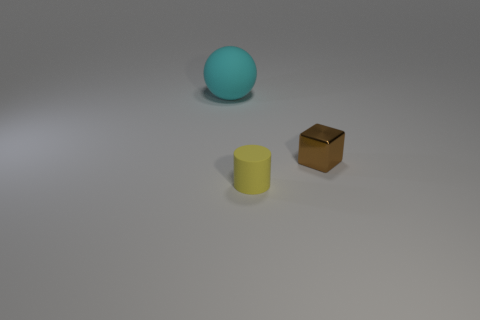What number of cyan rubber spheres have the same size as the brown shiny cube?
Your answer should be compact. 0. Does the small brown cube have the same material as the thing to the left of the small yellow rubber cylinder?
Your response must be concise. No. Are there fewer large gray matte things than tiny matte objects?
Ensure brevity in your answer.  Yes. Is there any other thing of the same color as the shiny block?
Offer a terse response. No. What is the shape of the big thing that is made of the same material as the cylinder?
Provide a succinct answer. Sphere. How many large balls are behind the rubber object right of the object to the left of the small yellow thing?
Your response must be concise. 1. The object that is both on the left side of the brown metal cube and behind the small yellow matte thing has what shape?
Your answer should be compact. Sphere. Is the number of cyan balls in front of the cyan ball less than the number of brown metal things?
Your answer should be very brief. Yes. What number of small objects are blocks or red things?
Give a very brief answer. 1. What is the size of the sphere?
Your response must be concise. Large. 